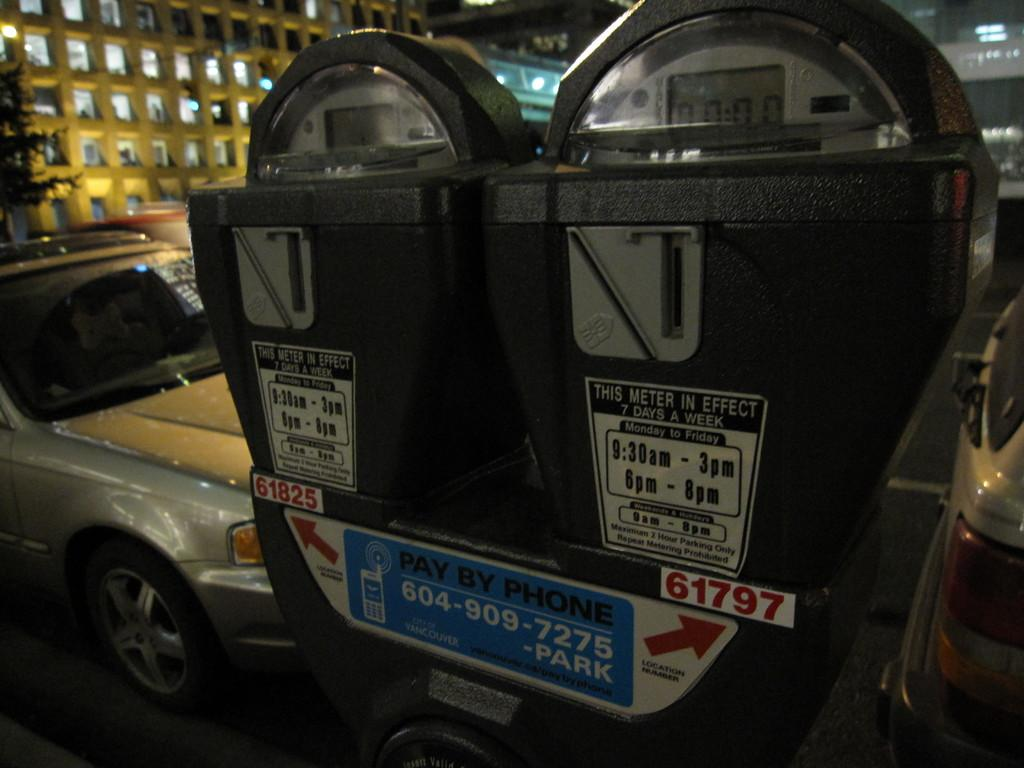<image>
Relay a brief, clear account of the picture shown. Two parking meters in front of a parked car that are in effect 7 days a week. 